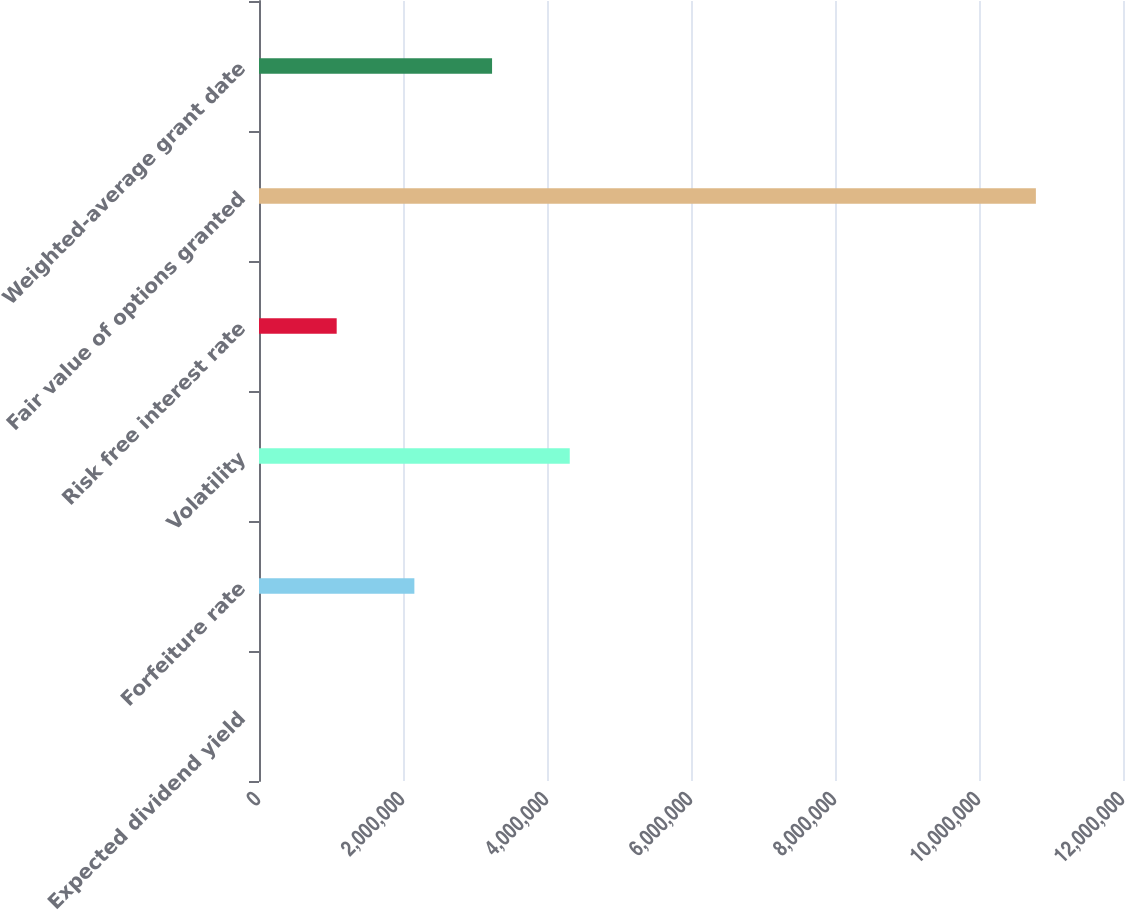Convert chart. <chart><loc_0><loc_0><loc_500><loc_500><bar_chart><fcel>Expected dividend yield<fcel>Forfeiture rate<fcel>Volatility<fcel>Risk free interest rate<fcel>Fair value of options granted<fcel>Weighted-average grant date<nl><fcel>0.91<fcel>2.158e+06<fcel>4.316e+06<fcel>1.079e+06<fcel>1.079e+07<fcel>3.237e+06<nl></chart> 